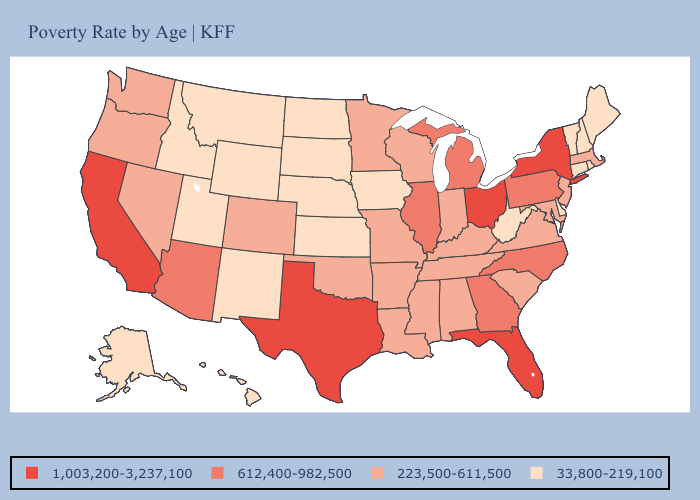Does Mississippi have the same value as Wisconsin?
Short answer required. Yes. Which states have the lowest value in the South?
Write a very short answer. Delaware, West Virginia. What is the value of Hawaii?
Answer briefly. 33,800-219,100. Does Virginia have the same value as Washington?
Short answer required. Yes. Which states hav the highest value in the South?
Concise answer only. Florida, Texas. Does Hawaii have a lower value than Montana?
Keep it brief. No. Which states hav the highest value in the Northeast?
Write a very short answer. New York. What is the lowest value in the Northeast?
Quick response, please. 33,800-219,100. What is the value of Maine?
Write a very short answer. 33,800-219,100. Does Massachusetts have a higher value than New York?
Short answer required. No. What is the value of West Virginia?
Answer briefly. 33,800-219,100. Name the states that have a value in the range 33,800-219,100?
Keep it brief. Alaska, Connecticut, Delaware, Hawaii, Idaho, Iowa, Kansas, Maine, Montana, Nebraska, New Hampshire, New Mexico, North Dakota, Rhode Island, South Dakota, Utah, Vermont, West Virginia, Wyoming. What is the value of Mississippi?
Concise answer only. 223,500-611,500. Name the states that have a value in the range 33,800-219,100?
Give a very brief answer. Alaska, Connecticut, Delaware, Hawaii, Idaho, Iowa, Kansas, Maine, Montana, Nebraska, New Hampshire, New Mexico, North Dakota, Rhode Island, South Dakota, Utah, Vermont, West Virginia, Wyoming. Name the states that have a value in the range 1,003,200-3,237,100?
Keep it brief. California, Florida, New York, Ohio, Texas. 